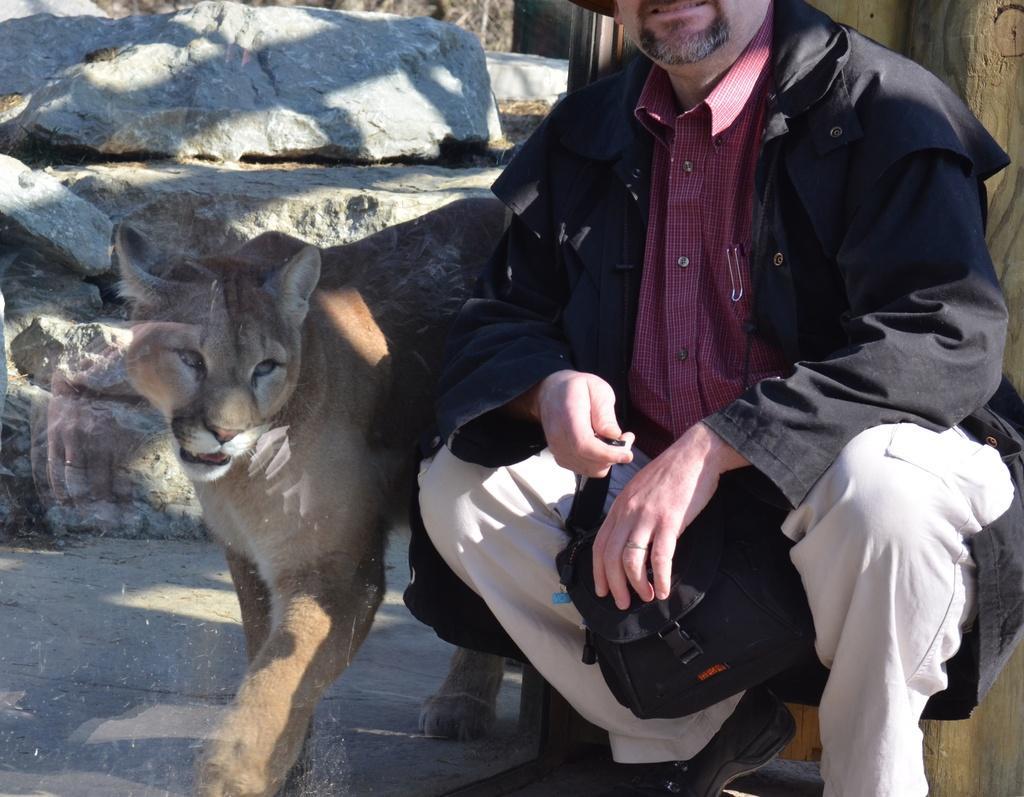Can you describe this image briefly? In the image we can see there is a person sitting beside a lioness and the person is wearing a black jacket. 